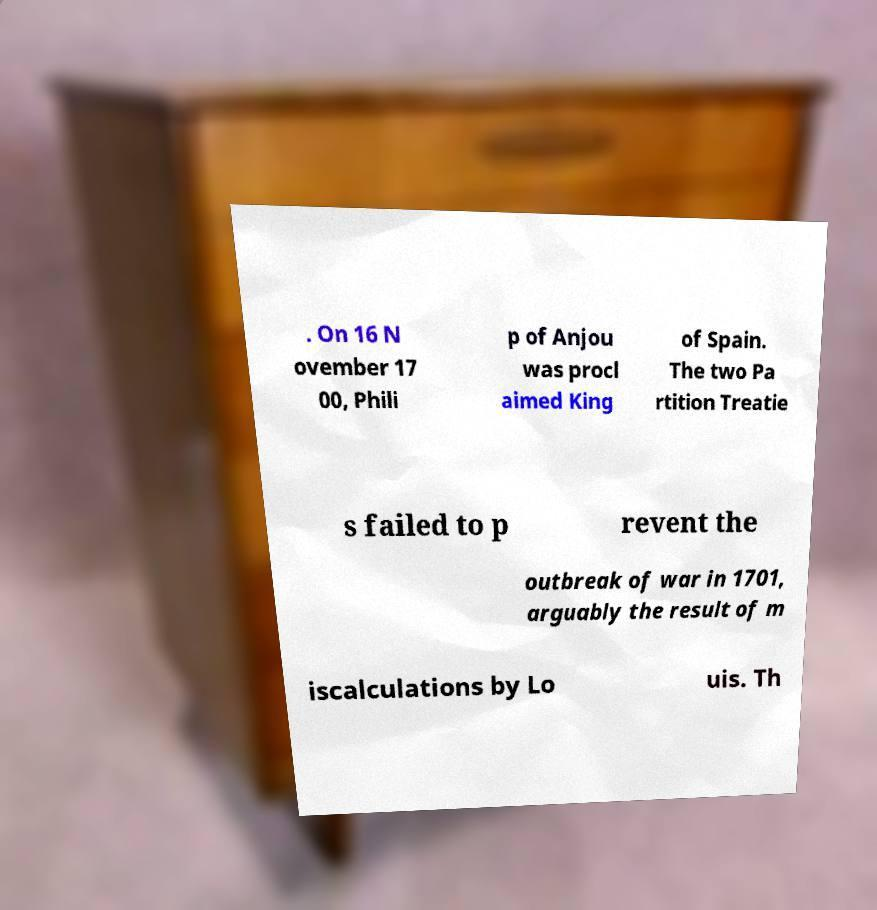Could you extract and type out the text from this image? . On 16 N ovember 17 00, Phili p of Anjou was procl aimed King of Spain. The two Pa rtition Treatie s failed to p revent the outbreak of war in 1701, arguably the result of m iscalculations by Lo uis. Th 